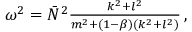Convert formula to latex. <formula><loc_0><loc_0><loc_500><loc_500>\begin{array} { r } { \omega ^ { 2 } = \bar { N } ^ { 2 } \frac { k ^ { 2 } + l ^ { 2 } } { m ^ { 2 } + ( 1 - \beta ) ( k ^ { 2 } + l ^ { 2 } ) } \, , } \end{array}</formula> 